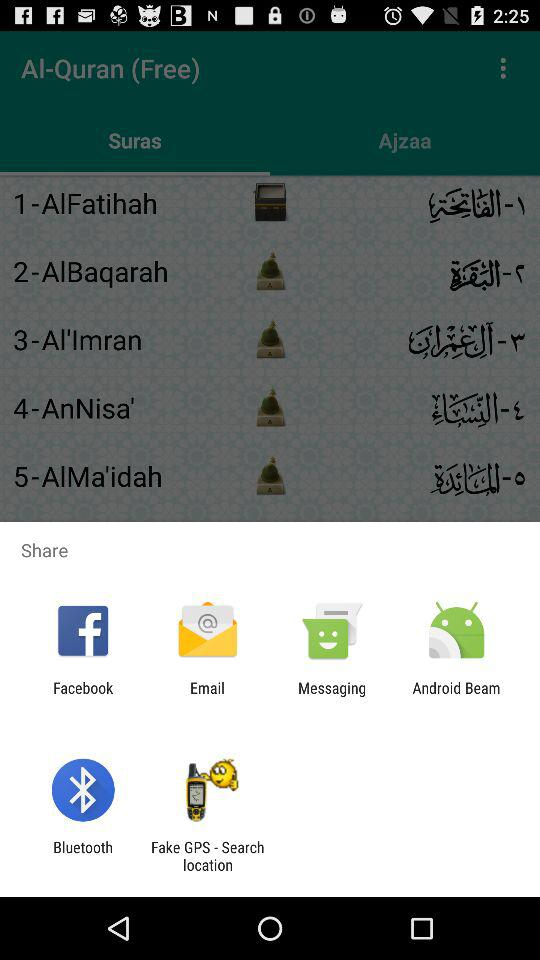What are the sharing options? You can share it with "Facebook", "Email", "Messaging", "Android Beam", "Bluetooth" and "Fake GPS - Search location". 